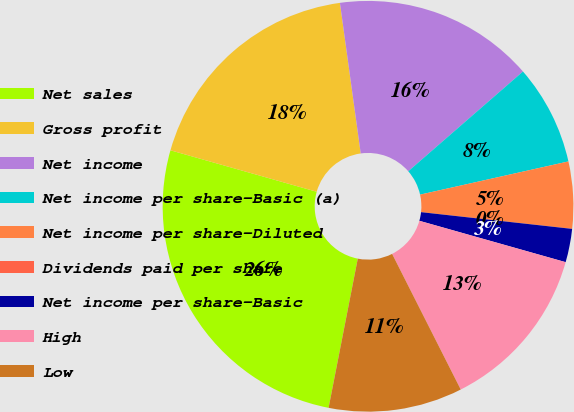Convert chart. <chart><loc_0><loc_0><loc_500><loc_500><pie_chart><fcel>Net sales<fcel>Gross profit<fcel>Net income<fcel>Net income per share-Basic (a)<fcel>Net income per share-Diluted<fcel>Dividends paid per share<fcel>Net income per share-Basic<fcel>High<fcel>Low<nl><fcel>26.32%<fcel>18.42%<fcel>15.79%<fcel>7.89%<fcel>5.26%<fcel>0.0%<fcel>2.63%<fcel>13.16%<fcel>10.53%<nl></chart> 